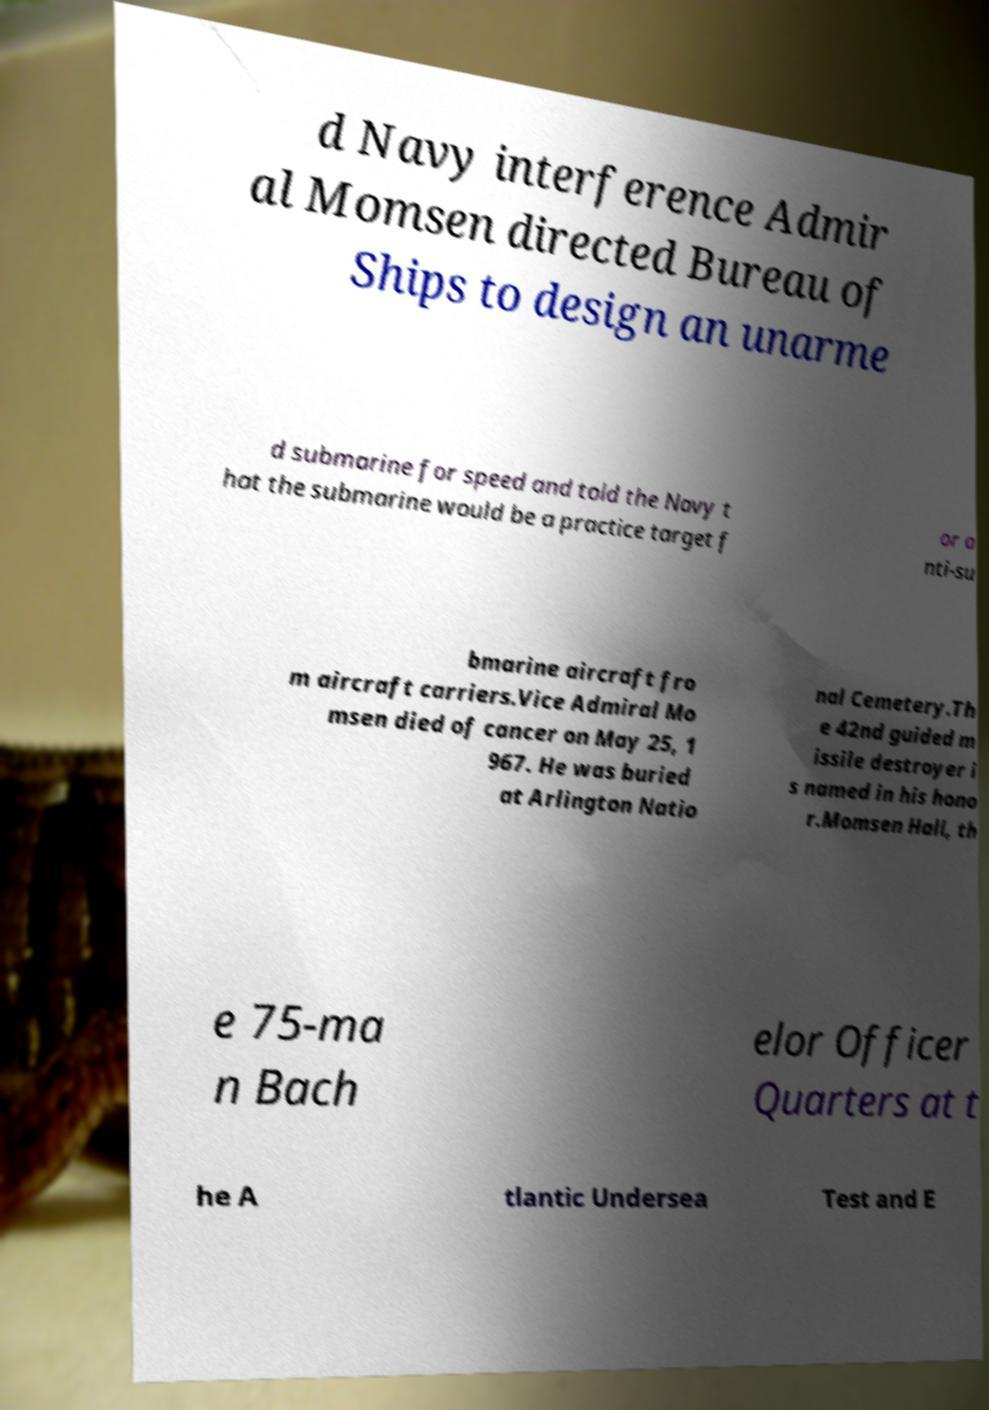Could you assist in decoding the text presented in this image and type it out clearly? d Navy interference Admir al Momsen directed Bureau of Ships to design an unarme d submarine for speed and told the Navy t hat the submarine would be a practice target f or a nti-su bmarine aircraft fro m aircraft carriers.Vice Admiral Mo msen died of cancer on May 25, 1 967. He was buried at Arlington Natio nal Cemetery.Th e 42nd guided m issile destroyer i s named in his hono r.Momsen Hall, th e 75-ma n Bach elor Officer Quarters at t he A tlantic Undersea Test and E 